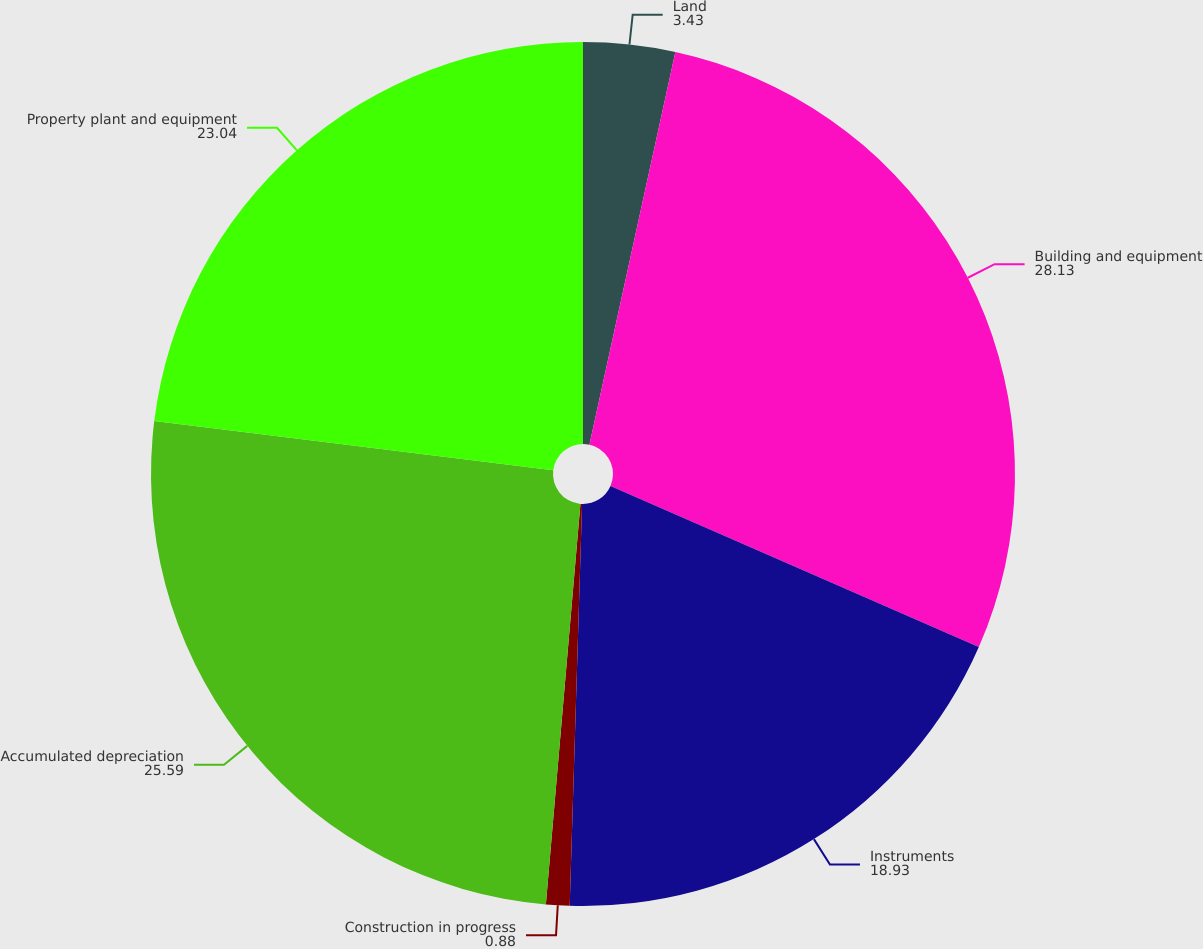<chart> <loc_0><loc_0><loc_500><loc_500><pie_chart><fcel>Land<fcel>Building and equipment<fcel>Instruments<fcel>Construction in progress<fcel>Accumulated depreciation<fcel>Property plant and equipment<nl><fcel>3.43%<fcel>28.13%<fcel>18.93%<fcel>0.88%<fcel>25.59%<fcel>23.04%<nl></chart> 